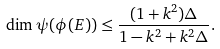Convert formula to latex. <formula><loc_0><loc_0><loc_500><loc_500>\dim \psi ( \phi ( E ) ) \leq \frac { ( 1 + k ^ { 2 } ) \Delta } { 1 - k ^ { 2 } + k ^ { 2 } \Delta } .</formula> 